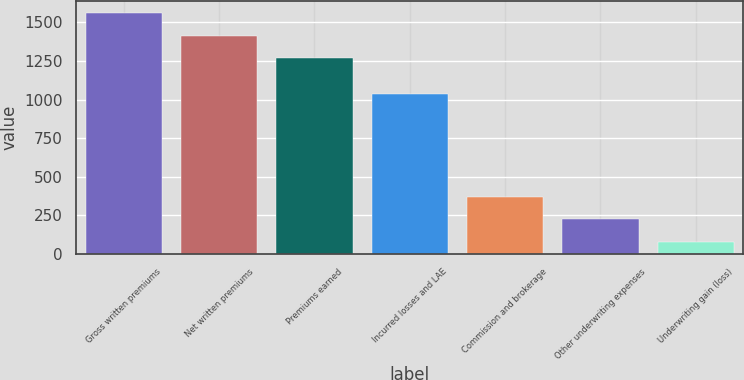Convert chart to OTSL. <chart><loc_0><loc_0><loc_500><loc_500><bar_chart><fcel>Gross written premiums<fcel>Net written premiums<fcel>Premiums earned<fcel>Incurred losses and LAE<fcel>Commission and brokerage<fcel>Other underwriting expenses<fcel>Underwriting gain (loss)<nl><fcel>1557.26<fcel>1411.98<fcel>1266.7<fcel>1033.3<fcel>370.06<fcel>224.78<fcel>79.5<nl></chart> 